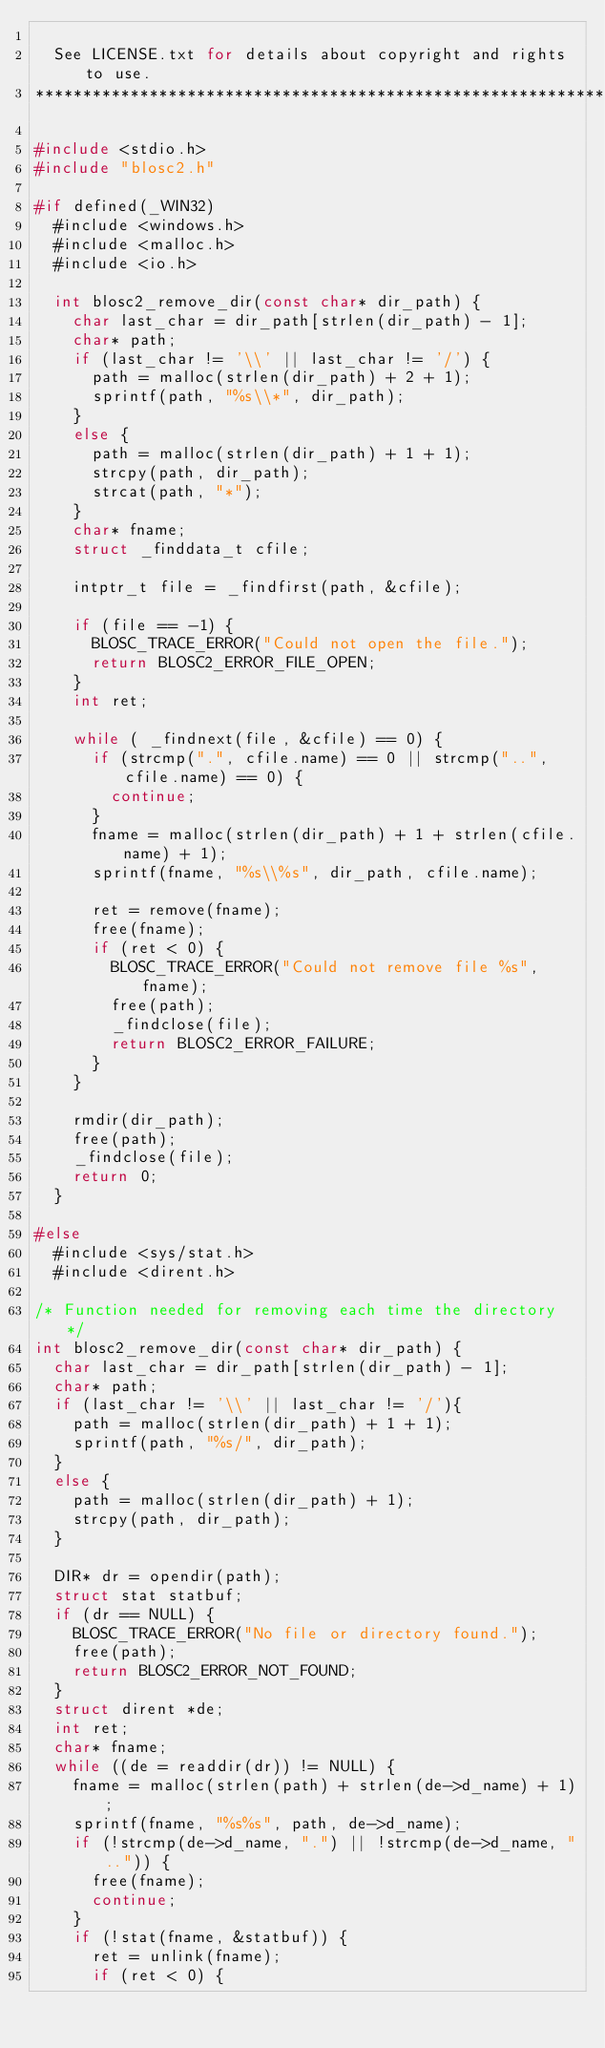<code> <loc_0><loc_0><loc_500><loc_500><_C_>
  See LICENSE.txt for details about copyright and rights to use.
**********************************************************************/

#include <stdio.h>
#include "blosc2.h"

#if defined(_WIN32)
  #include <windows.h>
  #include <malloc.h>
  #include <io.h>

  int blosc2_remove_dir(const char* dir_path) {
    char last_char = dir_path[strlen(dir_path) - 1];
    char* path;
    if (last_char != '\\' || last_char != '/') {
      path = malloc(strlen(dir_path) + 2 + 1);
      sprintf(path, "%s\\*", dir_path);
    }
    else {
      path = malloc(strlen(dir_path) + 1 + 1);
      strcpy(path, dir_path);
      strcat(path, "*");
    }
    char* fname;
    struct _finddata_t cfile;

    intptr_t file = _findfirst(path, &cfile);

    if (file == -1) {
      BLOSC_TRACE_ERROR("Could not open the file.");
      return BLOSC2_ERROR_FILE_OPEN;
    }
    int ret;

    while ( _findnext(file, &cfile) == 0) {
      if (strcmp(".", cfile.name) == 0 || strcmp("..", cfile.name) == 0) {
        continue;
      }
      fname = malloc(strlen(dir_path) + 1 + strlen(cfile.name) + 1);
      sprintf(fname, "%s\\%s", dir_path, cfile.name);

      ret = remove(fname);
      free(fname);
      if (ret < 0) {
        BLOSC_TRACE_ERROR("Could not remove file %s", fname);
        free(path);
        _findclose(file);
        return BLOSC2_ERROR_FAILURE;
      }
    }

    rmdir(dir_path);
    free(path);
    _findclose(file);
    return 0;
  }

#else
  #include <sys/stat.h>
  #include <dirent.h>

/* Function needed for removing each time the directory */
int blosc2_remove_dir(const char* dir_path) {
  char last_char = dir_path[strlen(dir_path) - 1];
  char* path;
  if (last_char != '\\' || last_char != '/'){
    path = malloc(strlen(dir_path) + 1 + 1);
    sprintf(path, "%s/", dir_path);
  }
  else {
    path = malloc(strlen(dir_path) + 1);
    strcpy(path, dir_path);
  }

  DIR* dr = opendir(path);
  struct stat statbuf;
  if (dr == NULL) {
    BLOSC_TRACE_ERROR("No file or directory found.");
    free(path);
    return BLOSC2_ERROR_NOT_FOUND;
  }
  struct dirent *de;
  int ret;
  char* fname;
  while ((de = readdir(dr)) != NULL) {
    fname = malloc(strlen(path) + strlen(de->d_name) + 1);
    sprintf(fname, "%s%s", path, de->d_name);
    if (!strcmp(de->d_name, ".") || !strcmp(de->d_name, "..")) {
      free(fname);
      continue;
    }
    if (!stat(fname, &statbuf)) {
      ret = unlink(fname);
      if (ret < 0) {</code> 